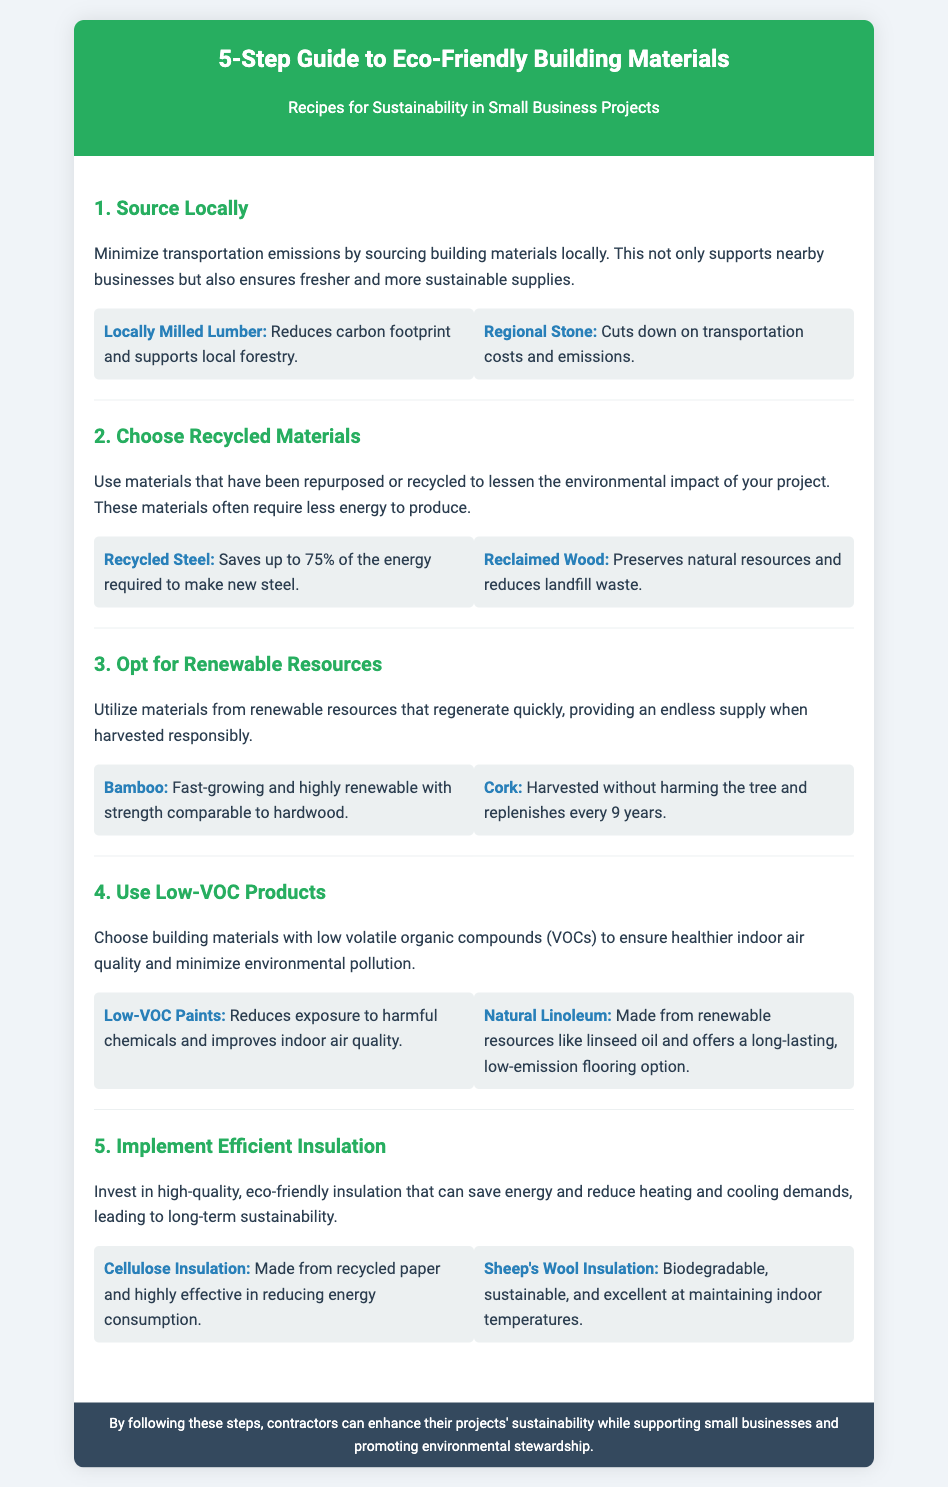what is the title of the document? The title is prominently displayed in the header of the document.
Answer: 5-Step Guide to Eco-Friendly Building Materials how many steps are outlined in the guide? The guide consists of five distinct steps mentioned in the document.
Answer: 5 what is the first step in the guide? The first step is clearly listed as the initial item in the steps section.
Answer: Source Locally name one example of a recycled material mentioned? The document provides specific examples under the second step regarding recycled materials.
Answer: Recycled Steel what is the benefit of using bamboo as per the guide? The text describes bamboo’s qualities related to sustainability and growth rate in the relevant step.
Answer: Fast-growing and highly renewable what type of insulation is made from recycled paper? The document explicitly identifies the type of insulation made from recycled materials in the final step.
Answer: Cellulose Insulation which product reduces exposure to harmful chemicals? This inquiry refers to a specific product stated in the section on low-VOC materials.
Answer: Low-VOC Paints what is the main focus of the document? The document’s primary aim is evident from its title and introductory statement.
Answer: Sustainability how does reclaimed wood benefit the environment? The document states the environmental advantages of using reclaimed wood in the second step.
Answer: Preserves natural resources and reduces landfill waste 